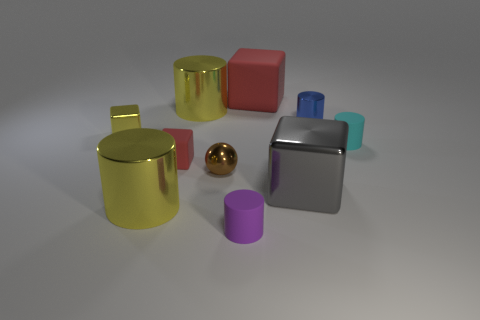Subtract all purple cylinders. How many cylinders are left? 4 Subtract all tiny blue metal cylinders. How many cylinders are left? 4 Subtract all brown cylinders. Subtract all gray cubes. How many cylinders are left? 5 Subtract all cubes. How many objects are left? 6 Add 3 small blue rubber objects. How many small blue rubber objects exist? 3 Subtract 1 gray blocks. How many objects are left? 9 Subtract all large shiny cylinders. Subtract all small metal spheres. How many objects are left? 7 Add 8 tiny yellow objects. How many tiny yellow objects are left? 9 